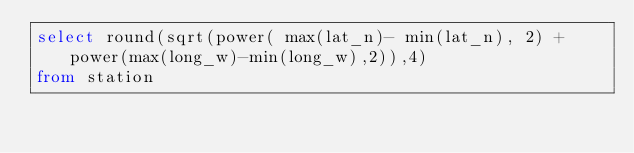Convert code to text. <code><loc_0><loc_0><loc_500><loc_500><_SQL_>select round(sqrt(power( max(lat_n)- min(lat_n), 2) + power(max(long_w)-min(long_w),2)),4) 
from station
</code> 